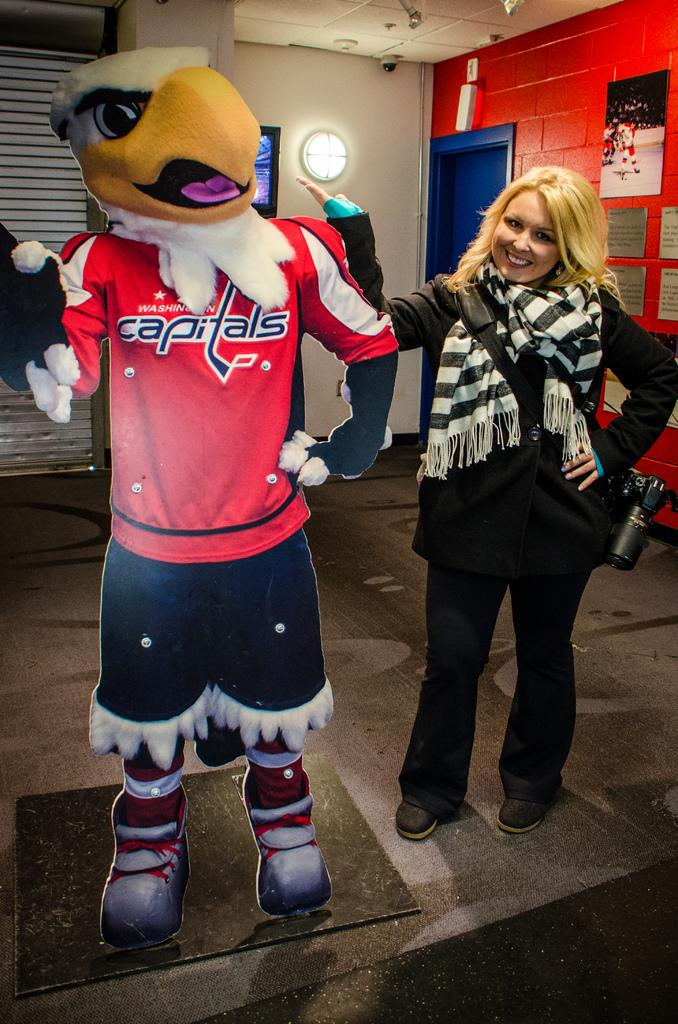<image>
Share a concise interpretation of the image provided. A woman is standing by a cardboard cutout of a Washington Capitals mascot. 